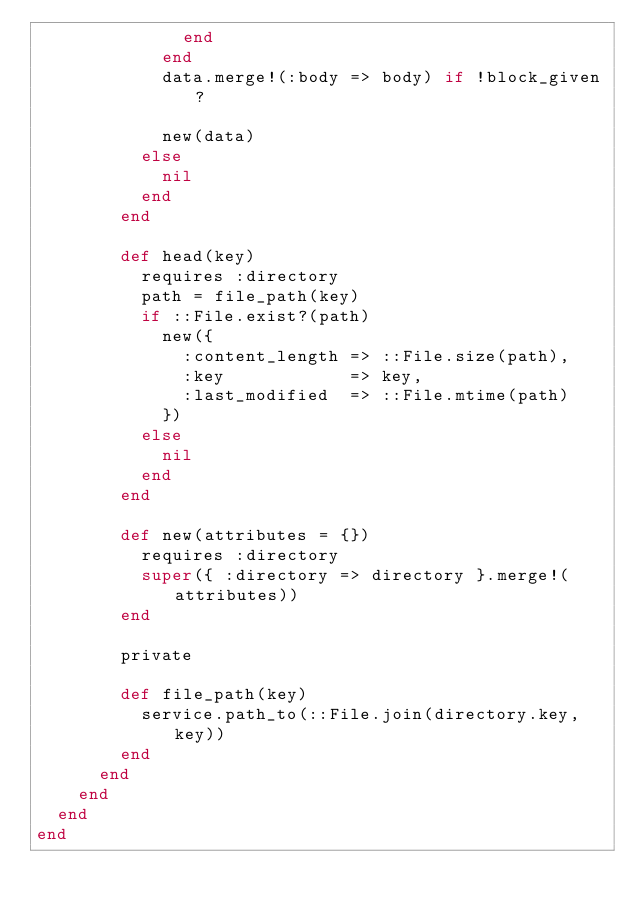<code> <loc_0><loc_0><loc_500><loc_500><_Ruby_>              end
            end
            data.merge!(:body => body) if !block_given?

            new(data)
          else
            nil
          end
        end

        def head(key)
          requires :directory
          path = file_path(key)
          if ::File.exist?(path)
            new({
              :content_length => ::File.size(path),
              :key            => key,
              :last_modified  => ::File.mtime(path)
            })
          else
            nil
          end
        end

        def new(attributes = {})
          requires :directory
          super({ :directory => directory }.merge!(attributes))
        end

        private

        def file_path(key)
          service.path_to(::File.join(directory.key, key))
        end
      end
    end
  end
end
</code> 